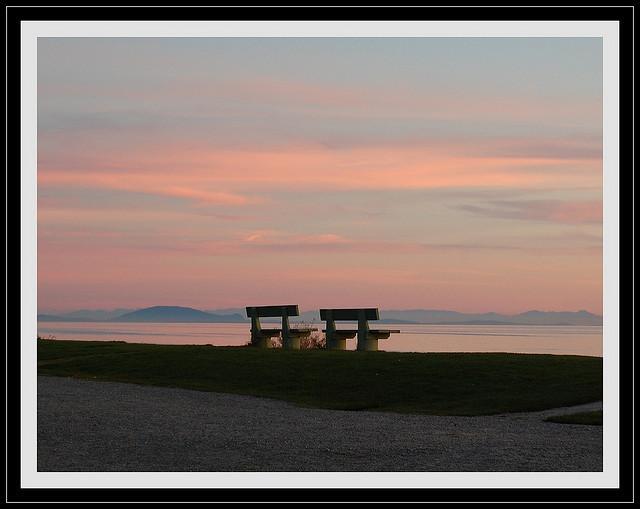Is this a new bench?
Short answer required. No. Is the water choppy?
Give a very brief answer. No. What time is it?
Quick response, please. Sunset. What major landform is featured in the background of the picture?
Give a very brief answer. Mountains. How many benches are photographed?
Answer briefly. 2. Is it daytime?
Give a very brief answer. No. What color is the sky?
Answer briefly. Orange. Are there hills in the background?
Short answer required. Yes. Is it sunset?
Keep it brief. Yes. What sort of tour is the photographer on?
Write a very short answer. Beach. 